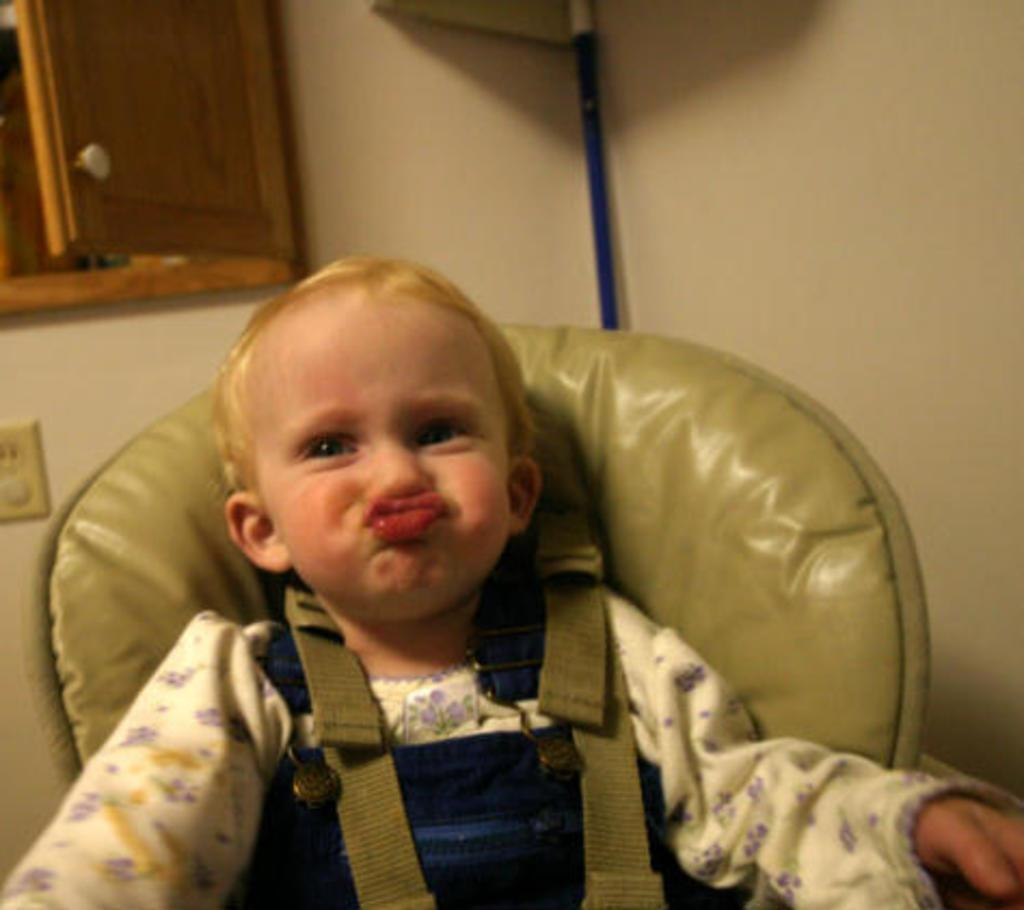What is the main subject of the image? The main subject of the image is a kid. What is the kid doing in the image? The kid is sitting on a chair in the image. What can be seen in the background of the image? There is a wall in the background of the image. Is there any furniture visible in the image? Yes, there is a cupboard in the top left corner of the image. What type of stem is holding up the cupboard in the image? There is no stem present in the image; the cupboard is supported by its own structure. 